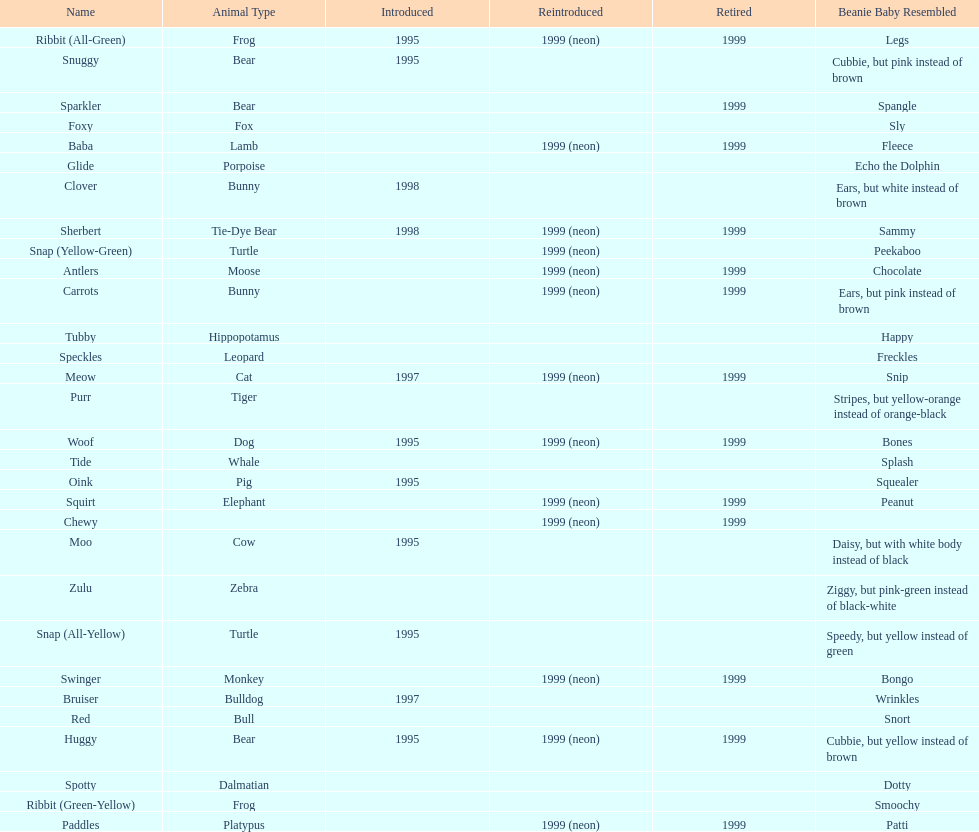Which animal type has the most pillow pals? Bear. 